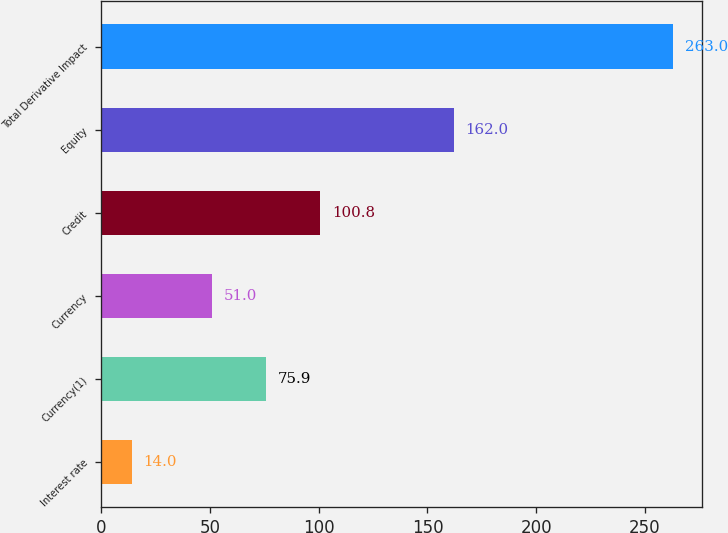Convert chart to OTSL. <chart><loc_0><loc_0><loc_500><loc_500><bar_chart><fcel>Interest rate<fcel>Currency(1)<fcel>Currency<fcel>Credit<fcel>Equity<fcel>Total Derivative Impact<nl><fcel>14<fcel>75.9<fcel>51<fcel>100.8<fcel>162<fcel>263<nl></chart> 